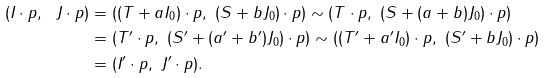Convert formula to latex. <formula><loc_0><loc_0><loc_500><loc_500>( I \cdot p , \ J \cdot p ) & = ( ( T + a I _ { 0 } ) \cdot p , \ ( S + b J _ { 0 } ) \cdot p ) \sim ( T \cdot p , \ ( S + ( a + b ) J _ { 0 } ) \cdot p ) \\ & = ( T ^ { \prime } \cdot p , \ ( S ^ { \prime } + ( a ^ { \prime } + b ^ { \prime } ) J _ { 0 } ) \cdot p ) \sim ( ( T ^ { \prime } + a ^ { \prime } I _ { 0 } ) \cdot p , \ ( S ^ { \prime } + b J _ { 0 } ) \cdot p ) \\ & = ( I ^ { \prime } \cdot p , \ J ^ { \prime } \cdot p ) .</formula> 